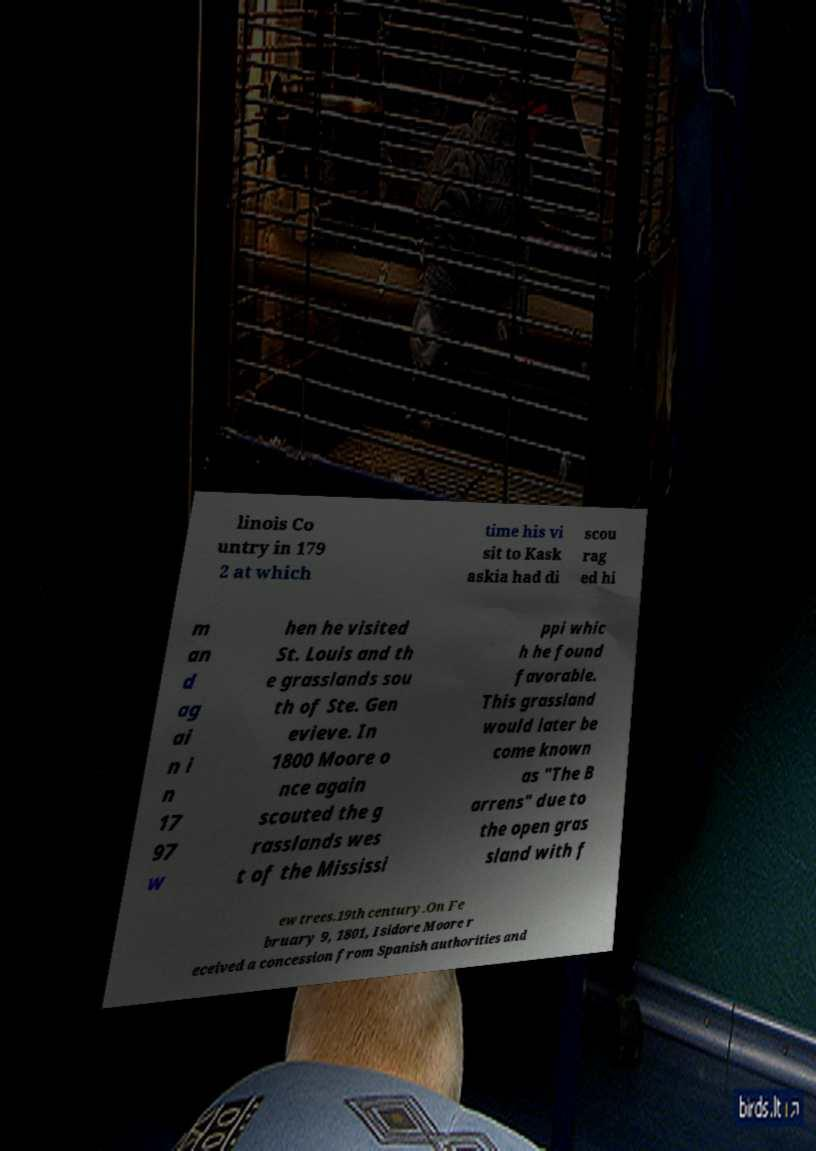Could you extract and type out the text from this image? linois Co untry in 179 2 at which time his vi sit to Kask askia had di scou rag ed hi m an d ag ai n i n 17 97 w hen he visited St. Louis and th e grasslands sou th of Ste. Gen evieve. In 1800 Moore o nce again scouted the g rasslands wes t of the Mississi ppi whic h he found favorable. This grassland would later be come known as "The B arrens" due to the open gras sland with f ew trees.19th century.On Fe bruary 9, 1801, Isidore Moore r eceived a concession from Spanish authorities and 